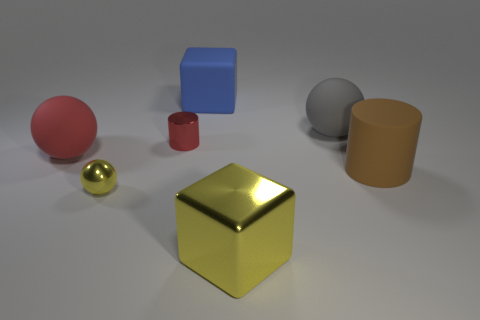Do the big sphere on the left side of the tiny yellow metal sphere and the cylinder that is to the left of the big yellow metallic object have the same color?
Ensure brevity in your answer.  Yes. There is a small metallic cylinder; how many metallic cubes are to the left of it?
Provide a succinct answer. 0. There is a large sphere that is the same color as the small metallic cylinder; what is it made of?
Provide a succinct answer. Rubber. Are there any big blue rubber things of the same shape as the brown matte thing?
Offer a very short reply. No. Is the big object in front of the brown matte cylinder made of the same material as the small thing to the right of the tiny yellow thing?
Make the answer very short. Yes. What is the size of the cylinder on the left side of the big cube that is in front of the cylinder that is in front of the small red cylinder?
Your answer should be very brief. Small. There is a red ball that is the same size as the yellow block; what is its material?
Make the answer very short. Rubber. Are there any yellow things that have the same size as the brown matte cylinder?
Your response must be concise. Yes. Is the shape of the brown object the same as the tiny red object?
Offer a very short reply. Yes. There is a metal object on the left side of the red thing that is behind the big red matte sphere; are there any small metallic objects behind it?
Provide a short and direct response. Yes. 